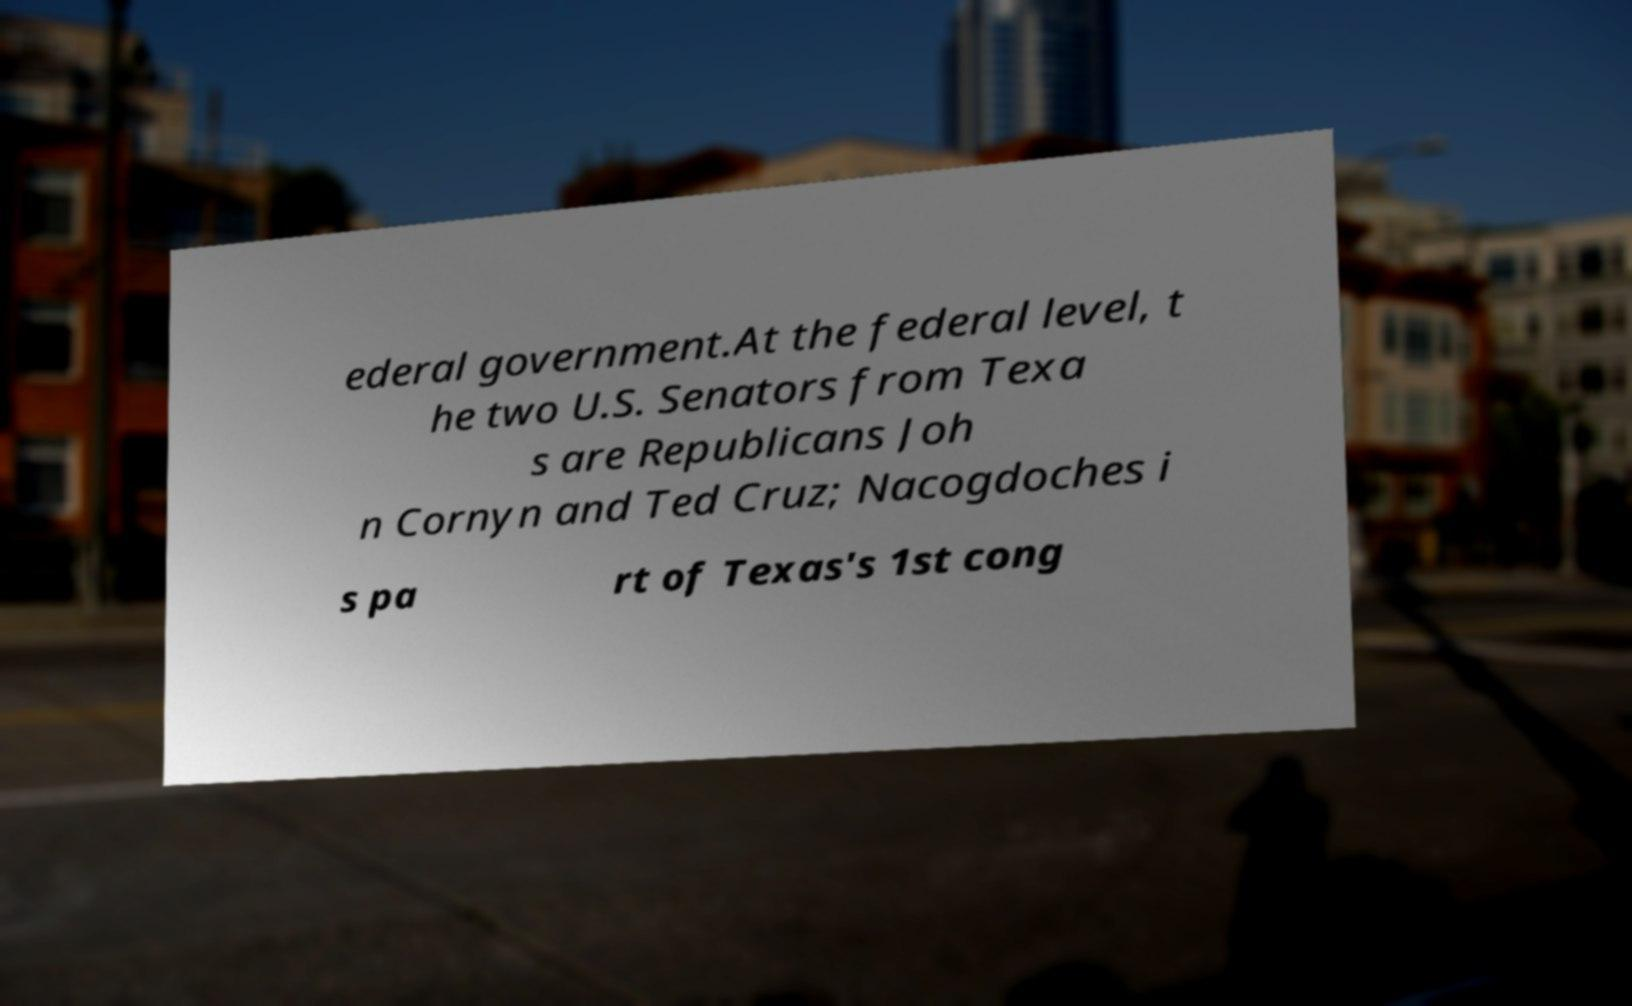Please identify and transcribe the text found in this image. ederal government.At the federal level, t he two U.S. Senators from Texa s are Republicans Joh n Cornyn and Ted Cruz; Nacogdoches i s pa rt of Texas's 1st cong 